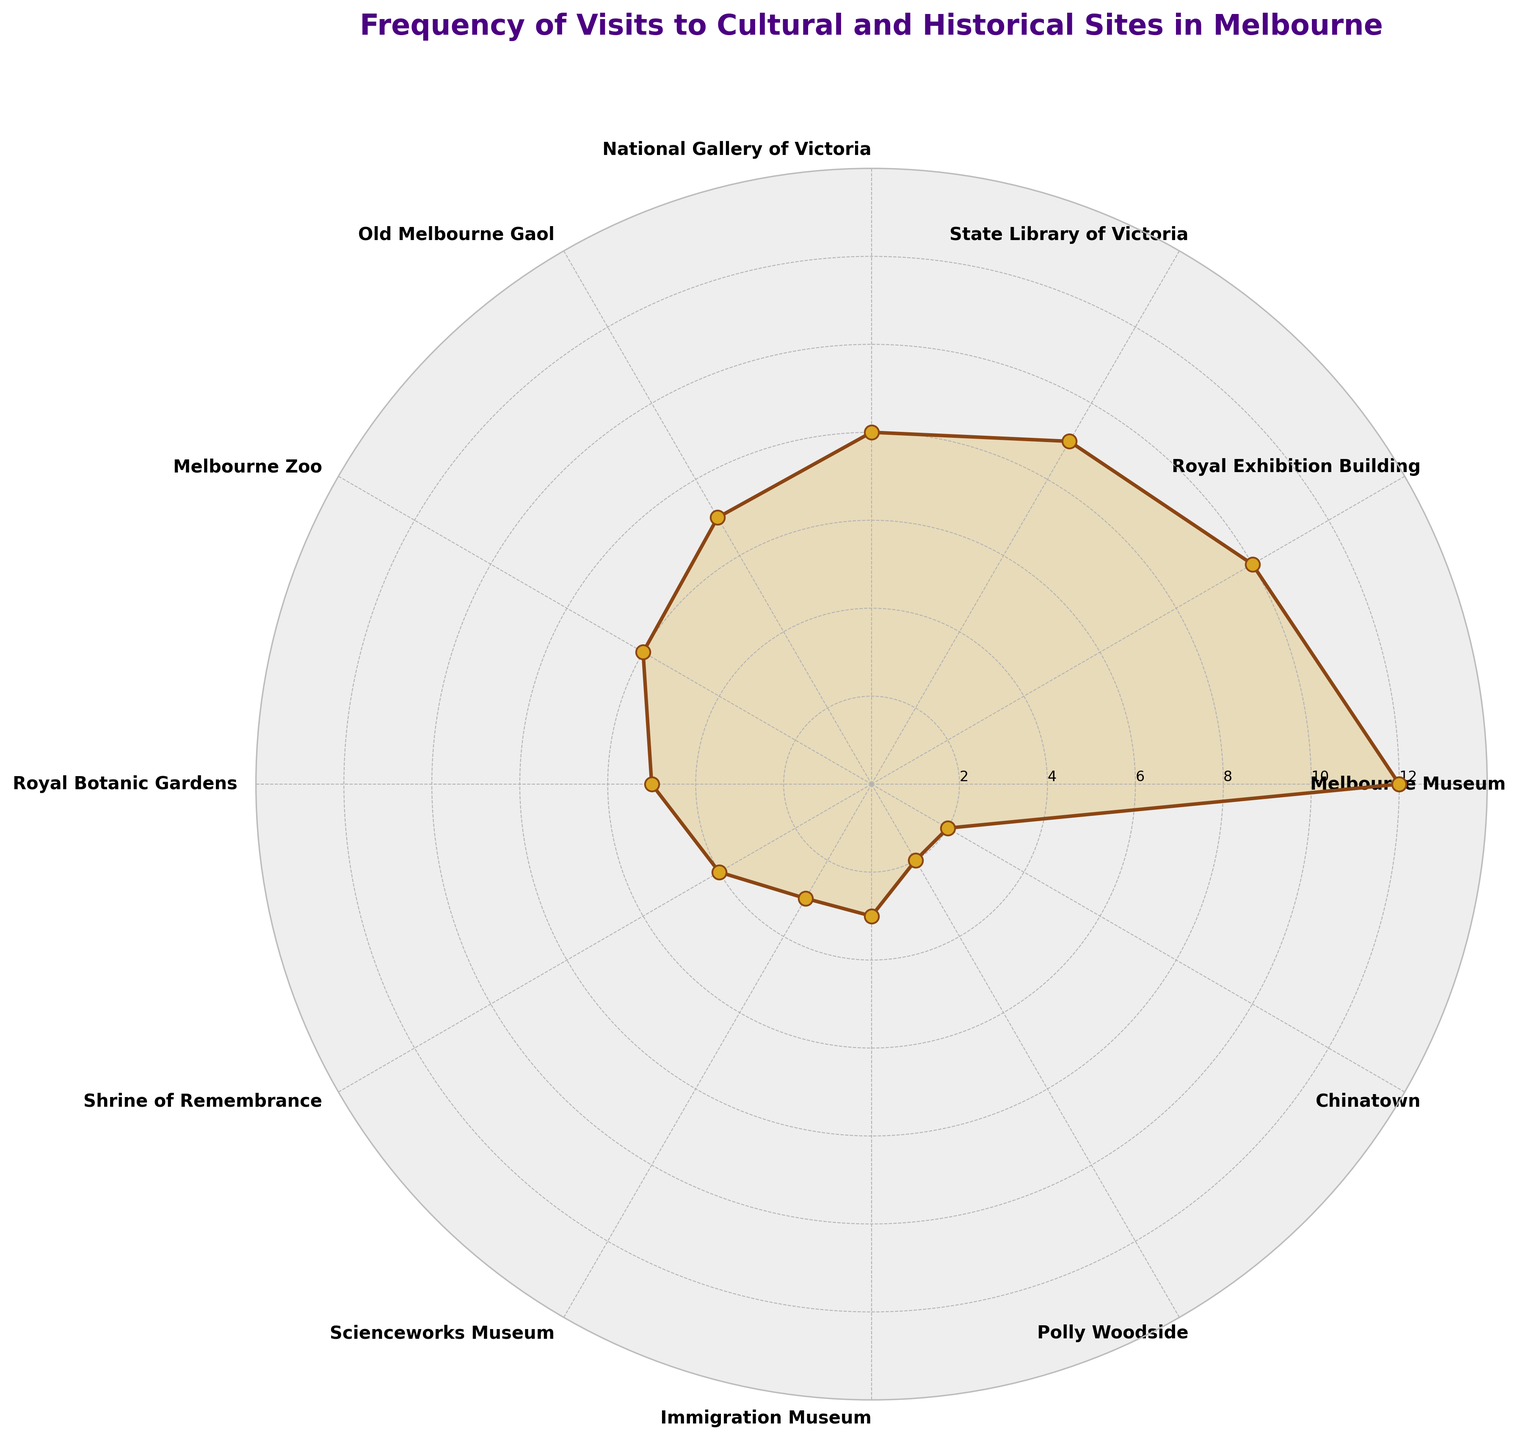What's the title of the figure? The title is found at the top of the figure. It summarizes the content of the chart.
Answer: Frequency of Visits to Cultural and Historical Sites in Melbourne How many places on the chart have a frequency of visits equal to 2? Count the categories where the frequency is exactly 2 in the chart. Here, Polly Woodside and Chinatown have a frequency of 2.
Answer: 2 What is the difference in visit frequency between Melbourne Museum and Old Melbourne Gaol? Look at the frequencies for Melbourne Museum (12) and Old Melbourne Gaol (7), then subtract the latter from the former. 12 - 7 = 5.
Answer: 5 Which cultural site has the second highest visit frequency and what is it? Identify the highest frequency first (Melbourne Museum at 12), then find the next highest (Royal Exhibition Building at 10).
Answer: Royal Exhibition Building at 10 What is the lowest visit frequency shown in the chart? Locate the smallest number on the frequency scale. The lowest is 2, which corresponds to Polly Woodside and Chinatown.
Answer: 2 How many places have a visit frequency greater than 8? Identify the categories with frequencies above 8: Melbourne Museum (12), Royal Exhibition Building (10), and State Library of Victoria (9). There are 3 places.
Answer: 3 What is the average visit frequency of Scienceworks Museum, Immigration Museum, and Polly Woodside? Add the frequencies of Scienceworks Museum (3), Immigration Museum (3), and Polly Woodside (2), then divide by 3 to find the average. (3 + 3 + 2) / 3 = 8 / 3 ≈ 2.67.
Answer: 2.67 Which place has a visit frequency exactly in the middle (median) of all listed sites and what is it? There are 12 sites, so the median will be the average of the 6th and 7th frequencies in order. Royal Botanic Gardens (5) and Melbourne Zoo (6). Thus, the median is (5+6)/2 = 5.5.
Answer: 5.5 Which site falls between State Library of Victoria and Melbourne Zoo in terms of visit frequency? Identify the frequencies of State Library of Victoria (9) and Melbourne Zoo (6). The places in between them by frequency are National Gallery of Victoria (8) and Old Melbourne Gaol (7).
Answer: National Gallery of Victoria and Old Melbourne Gaol 